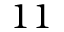Convert formula to latex. <formula><loc_0><loc_0><loc_500><loc_500>1 1</formula> 